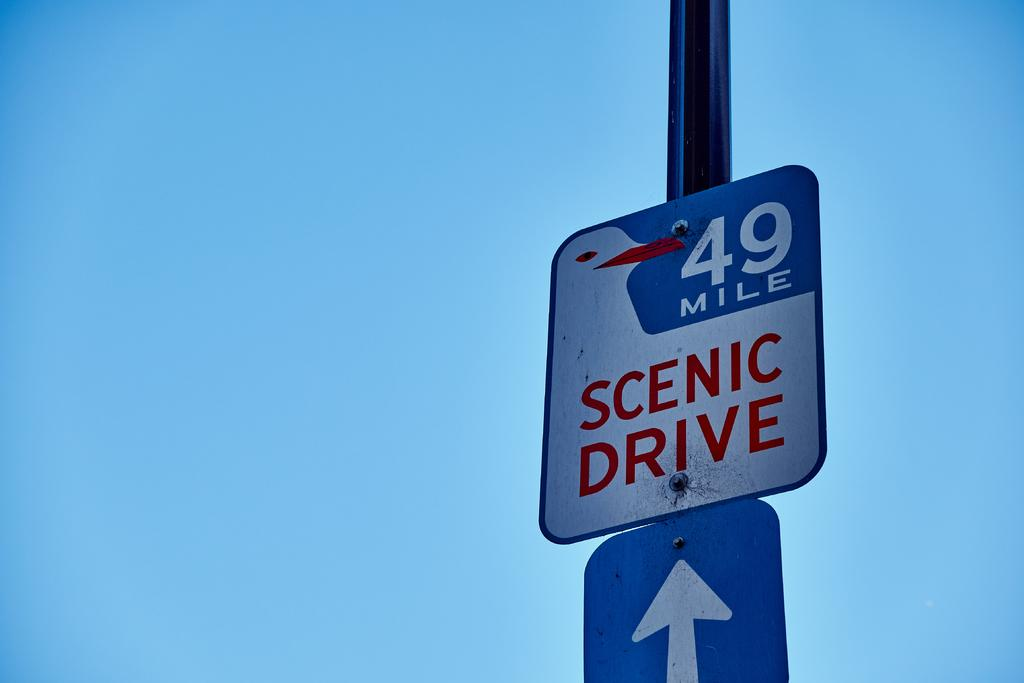Provide a one-sentence caption for the provided image. A 49 Mile Scenic Drive sign sits above a white arrow, against a backdrop of a bright blue sky. 